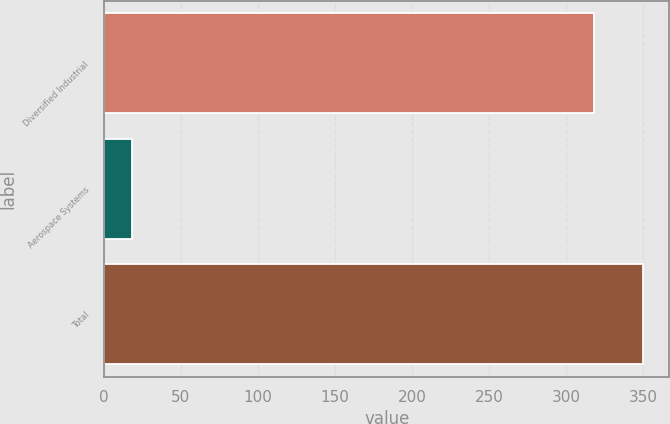Convert chart to OTSL. <chart><loc_0><loc_0><loc_500><loc_500><bar_chart><fcel>Diversified Industrial<fcel>Aerospace Systems<fcel>Total<nl><fcel>318<fcel>18<fcel>349.8<nl></chart> 